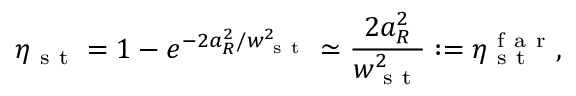Convert formula to latex. <formula><loc_0><loc_0><loc_500><loc_500>\eta _ { s t } = 1 - e ^ { - 2 a _ { R } ^ { 2 } / w _ { s t } ^ { 2 } } \simeq \frac { 2 a _ { R } ^ { 2 } } { w _ { s t } ^ { 2 } } \colon = \eta _ { s t } ^ { f a r } ,</formula> 